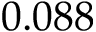Convert formula to latex. <formula><loc_0><loc_0><loc_500><loc_500>0 . 0 8 8</formula> 